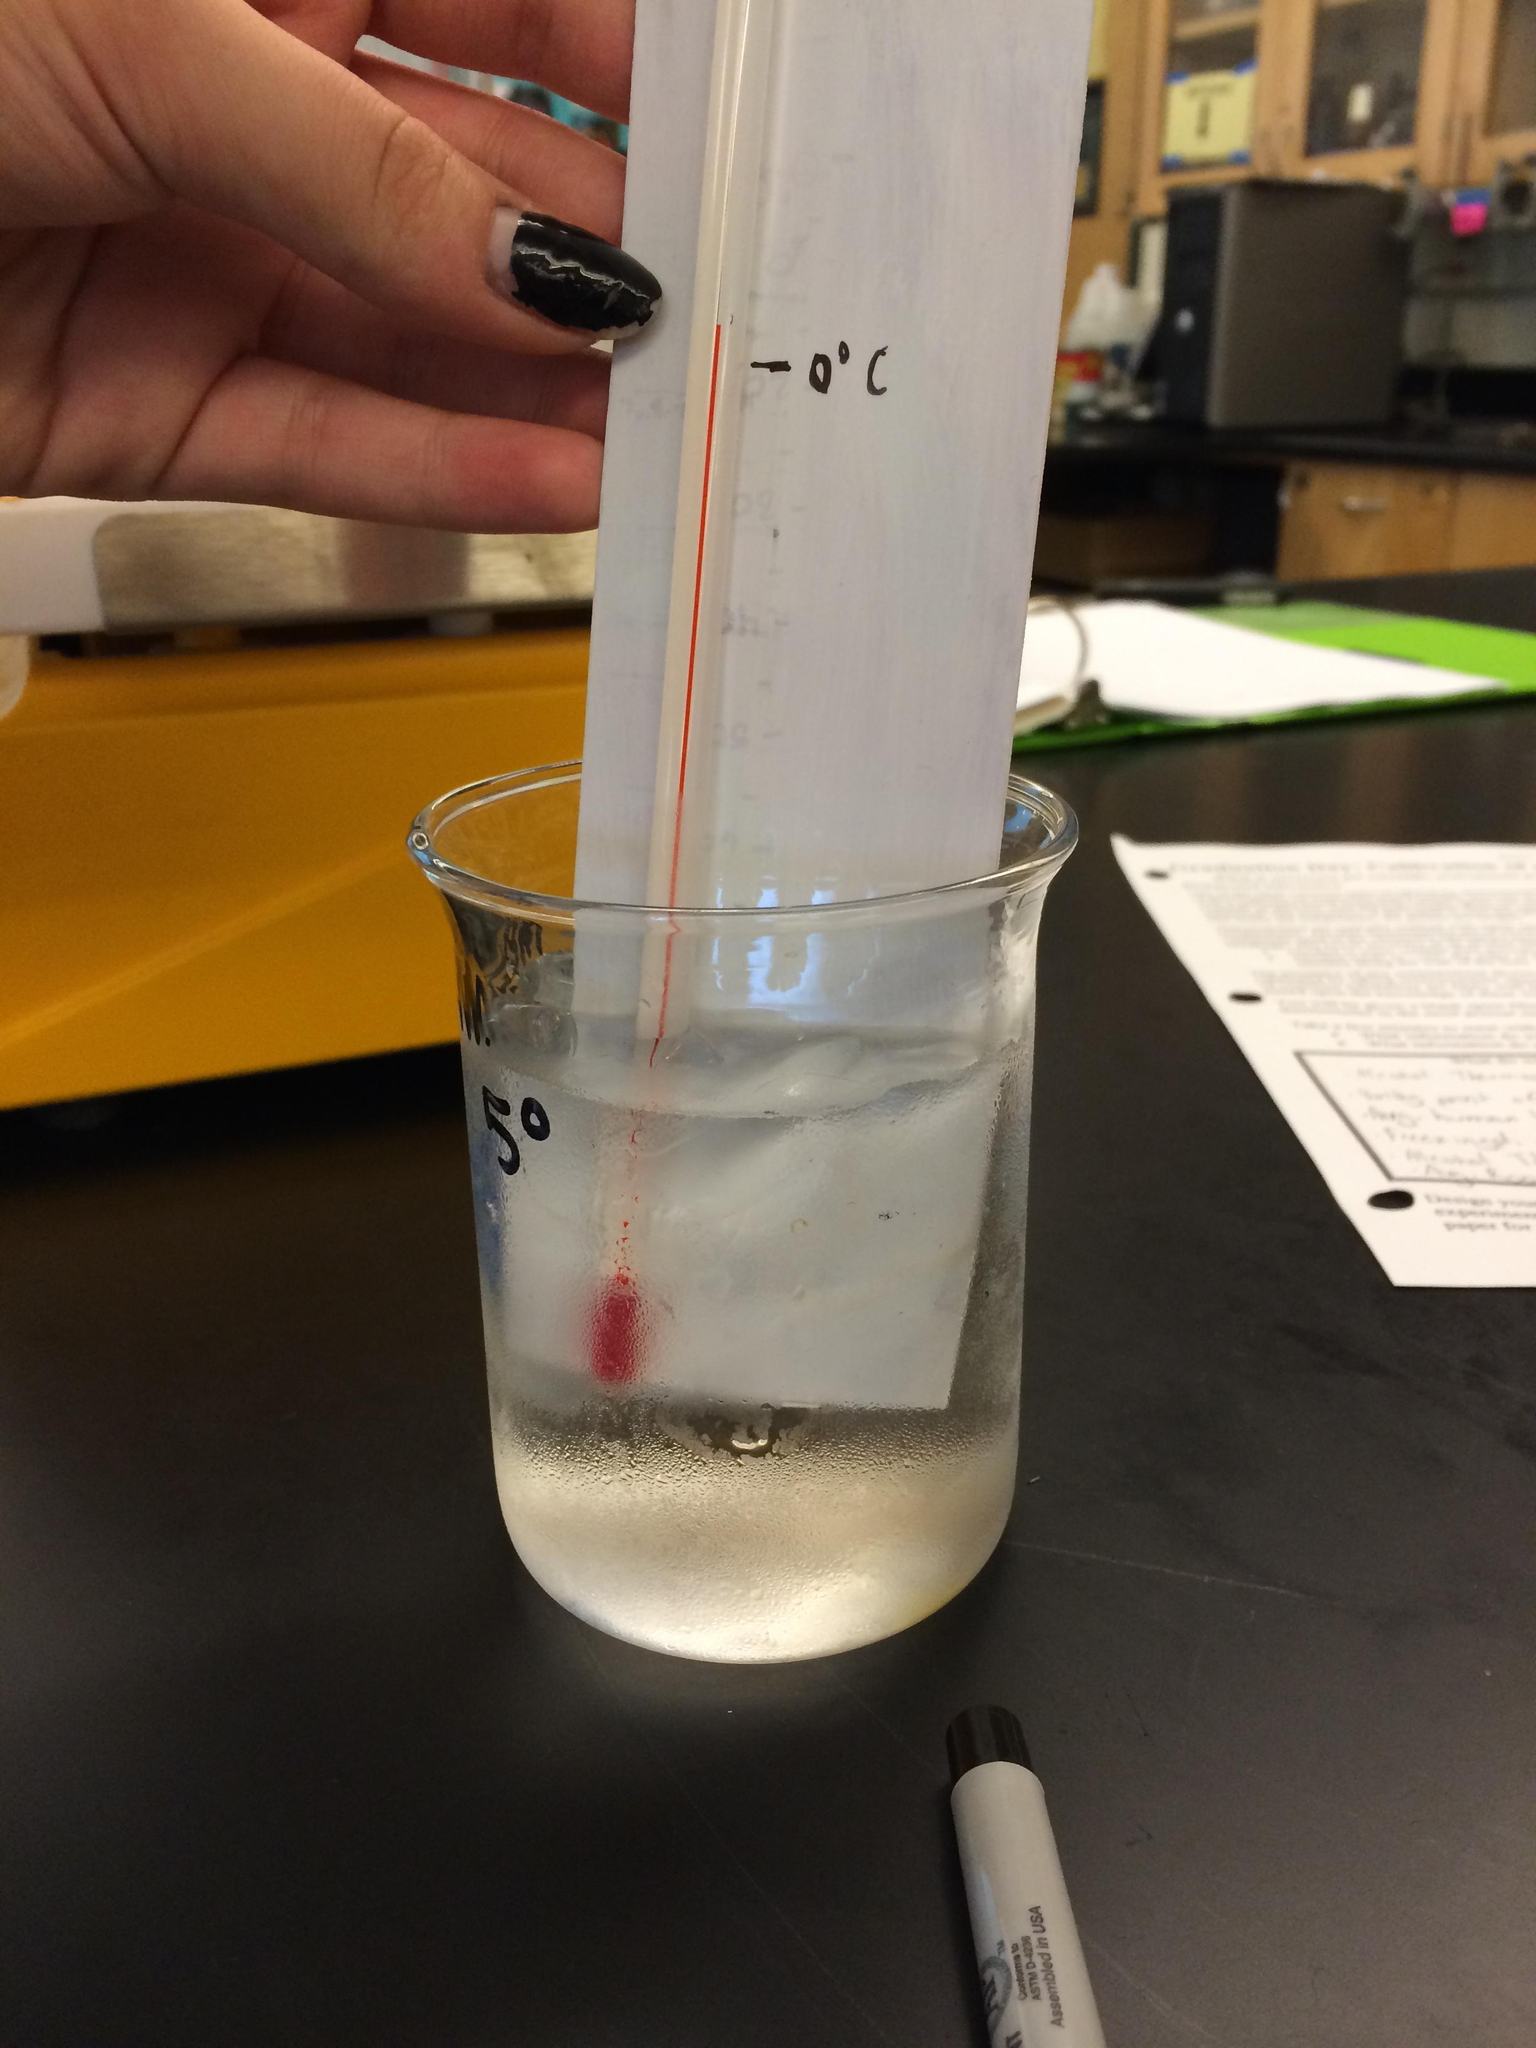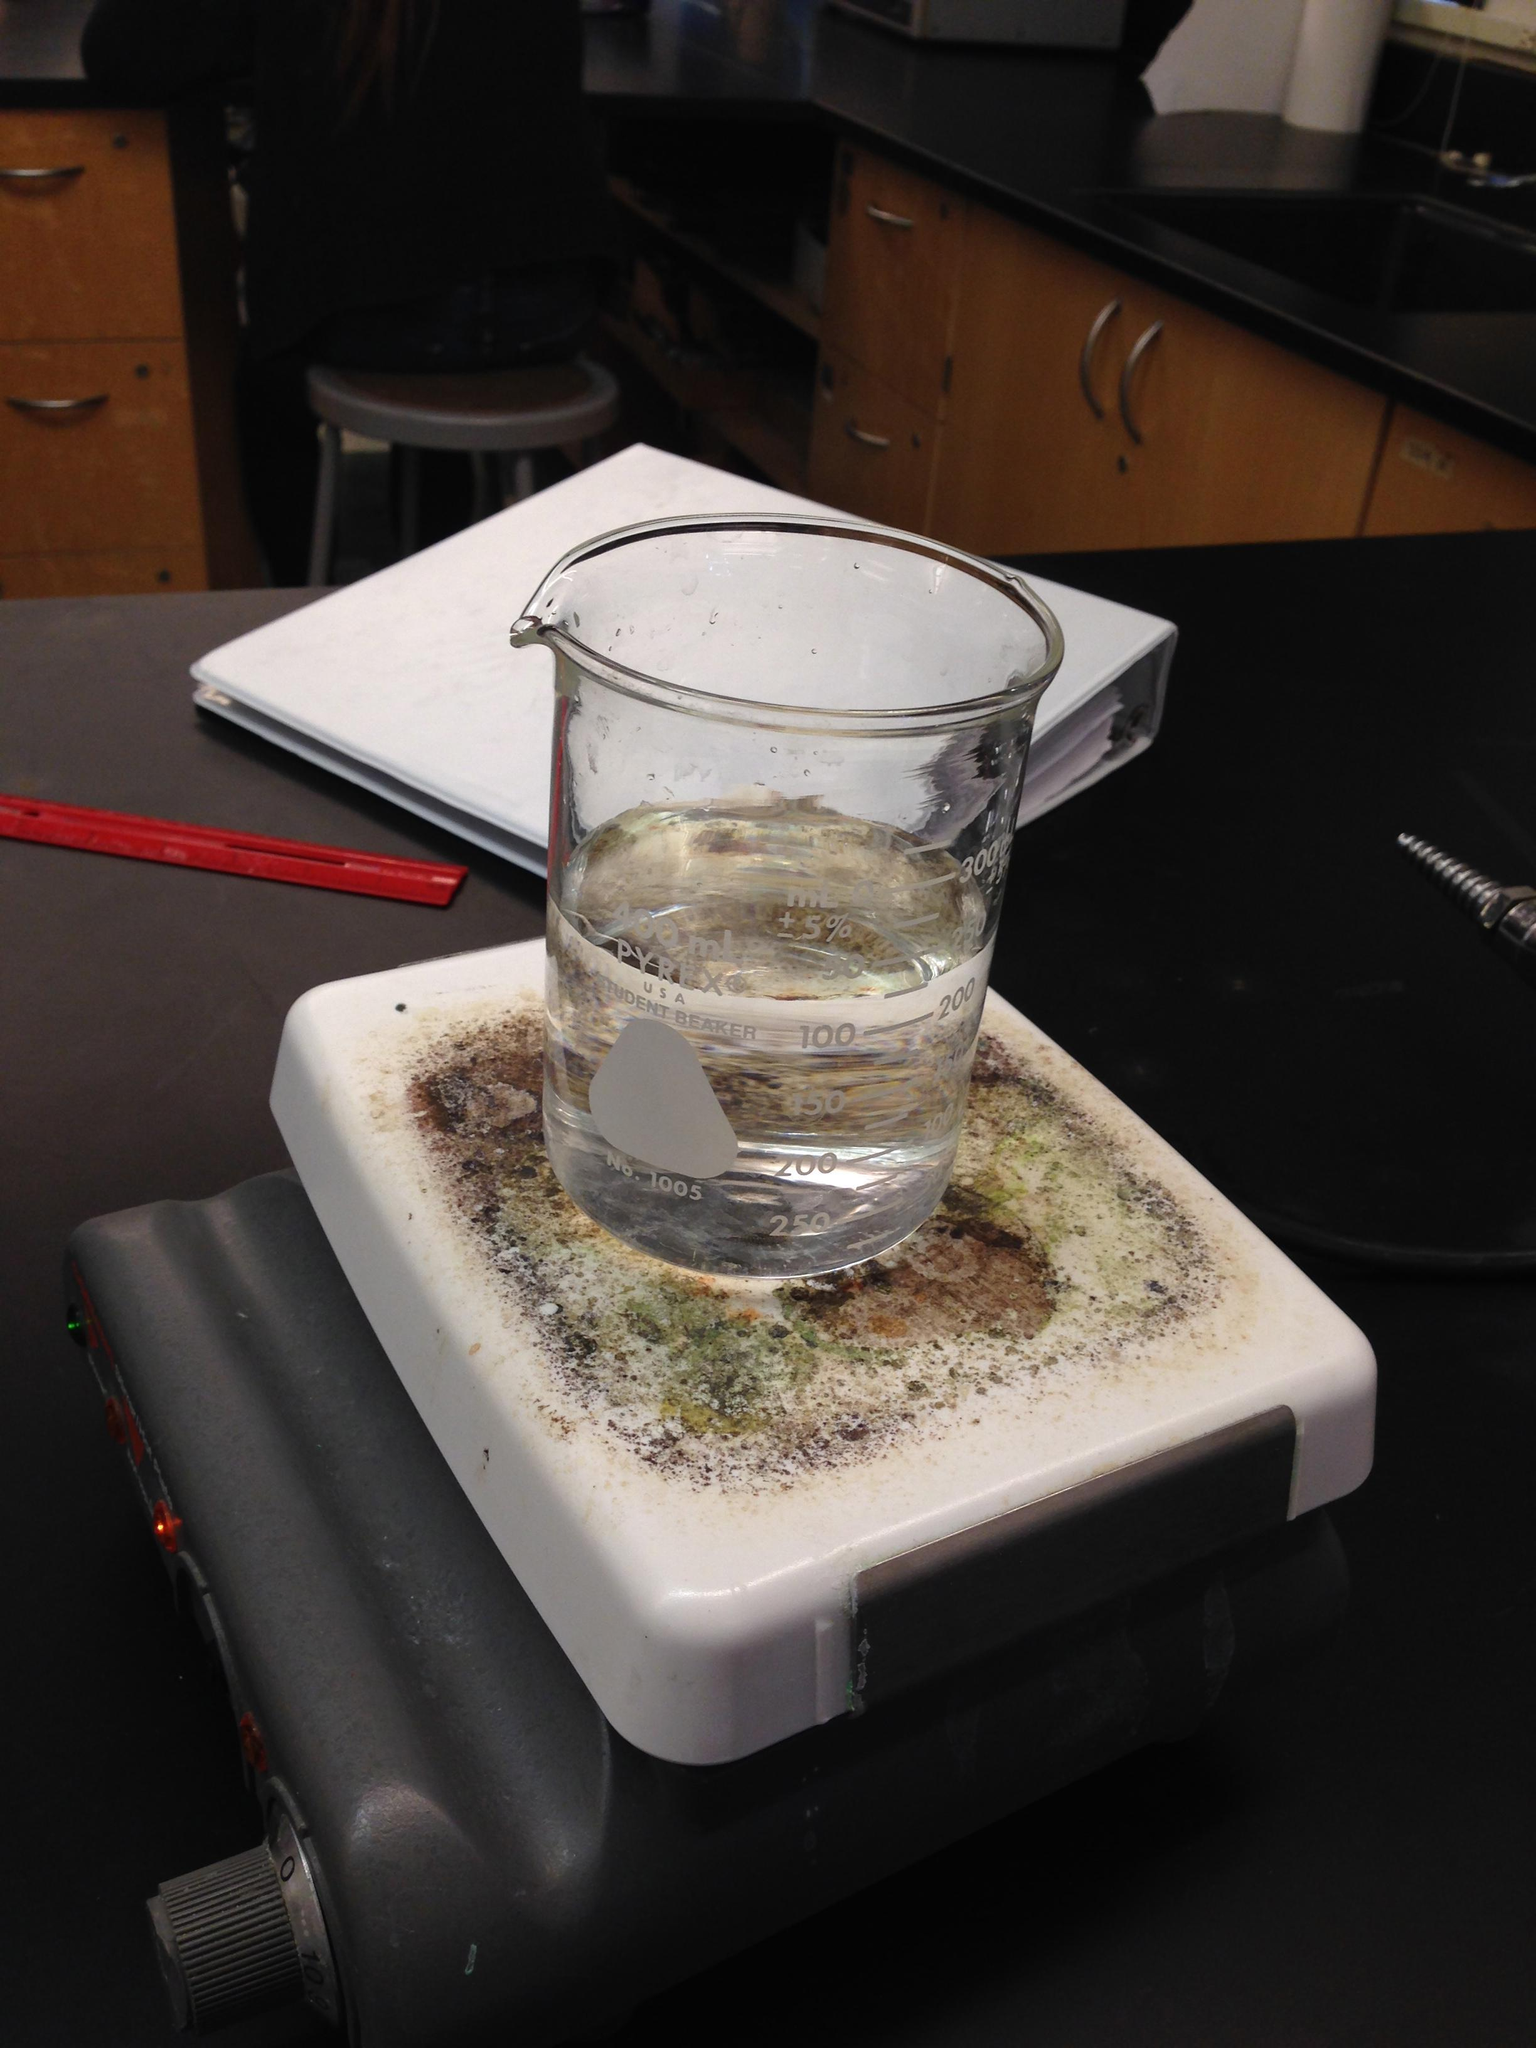The first image is the image on the left, the second image is the image on the right. Evaluate the accuracy of this statement regarding the images: "At least three cylindrical beakers hold a clear liquid.". Is it true? Answer yes or no. No. The first image is the image on the left, the second image is the image on the right. Given the left and right images, does the statement "There appear to be exactly three containers visible." hold true? Answer yes or no. No. 